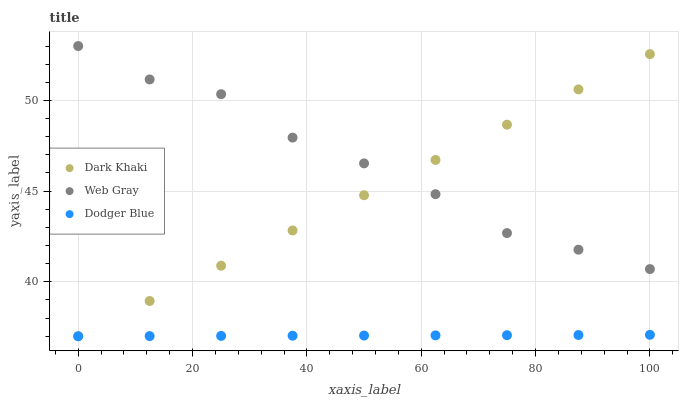Does Dodger Blue have the minimum area under the curve?
Answer yes or no. Yes. Does Web Gray have the maximum area under the curve?
Answer yes or no. Yes. Does Web Gray have the minimum area under the curve?
Answer yes or no. No. Does Dodger Blue have the maximum area under the curve?
Answer yes or no. No. Is Dark Khaki the smoothest?
Answer yes or no. Yes. Is Web Gray the roughest?
Answer yes or no. Yes. Is Dodger Blue the smoothest?
Answer yes or no. No. Is Dodger Blue the roughest?
Answer yes or no. No. Does Dark Khaki have the lowest value?
Answer yes or no. Yes. Does Web Gray have the lowest value?
Answer yes or no. No. Does Web Gray have the highest value?
Answer yes or no. Yes. Does Dodger Blue have the highest value?
Answer yes or no. No. Is Dodger Blue less than Web Gray?
Answer yes or no. Yes. Is Web Gray greater than Dodger Blue?
Answer yes or no. Yes. Does Dodger Blue intersect Dark Khaki?
Answer yes or no. Yes. Is Dodger Blue less than Dark Khaki?
Answer yes or no. No. Is Dodger Blue greater than Dark Khaki?
Answer yes or no. No. Does Dodger Blue intersect Web Gray?
Answer yes or no. No. 